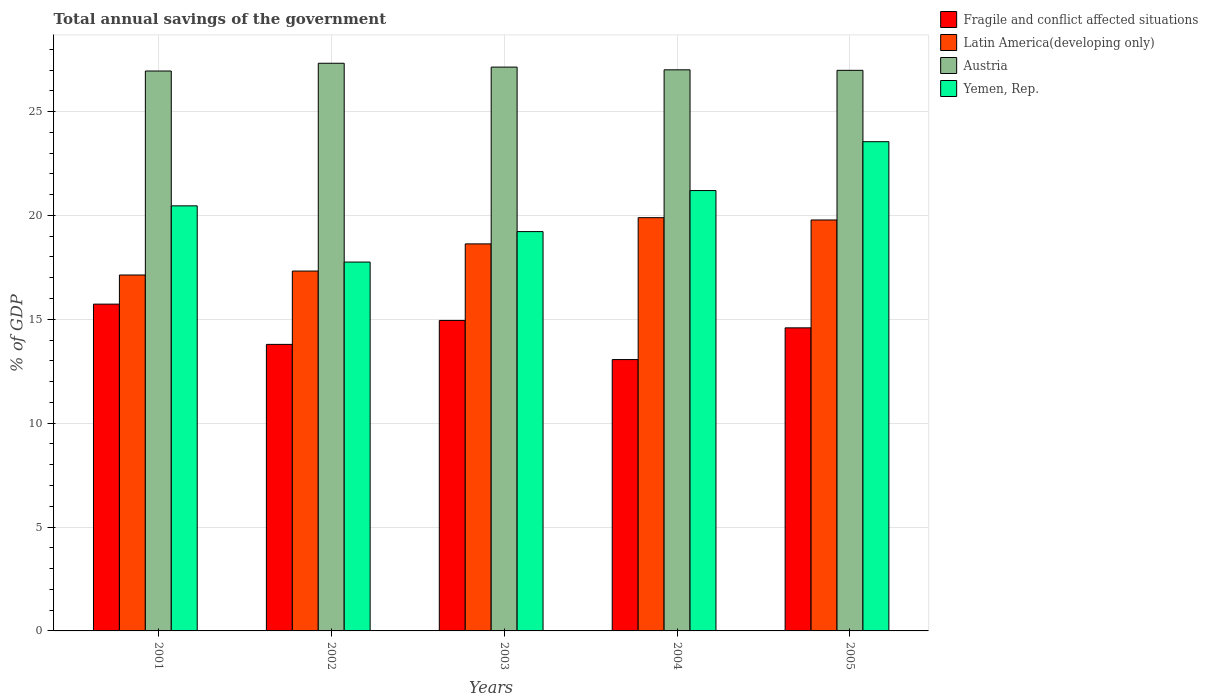How many different coloured bars are there?
Provide a succinct answer. 4. Are the number of bars per tick equal to the number of legend labels?
Provide a short and direct response. Yes. Are the number of bars on each tick of the X-axis equal?
Your answer should be compact. Yes. How many bars are there on the 2nd tick from the left?
Offer a terse response. 4. In how many cases, is the number of bars for a given year not equal to the number of legend labels?
Offer a very short reply. 0. What is the total annual savings of the government in Austria in 2005?
Your response must be concise. 26.99. Across all years, what is the maximum total annual savings of the government in Yemen, Rep.?
Your answer should be compact. 23.55. Across all years, what is the minimum total annual savings of the government in Yemen, Rep.?
Keep it short and to the point. 17.76. In which year was the total annual savings of the government in Fragile and conflict affected situations maximum?
Your answer should be compact. 2001. In which year was the total annual savings of the government in Austria minimum?
Make the answer very short. 2001. What is the total total annual savings of the government in Austria in the graph?
Give a very brief answer. 135.41. What is the difference between the total annual savings of the government in Latin America(developing only) in 2002 and that in 2003?
Keep it short and to the point. -1.31. What is the difference between the total annual savings of the government in Austria in 2003 and the total annual savings of the government in Latin America(developing only) in 2004?
Provide a succinct answer. 7.25. What is the average total annual savings of the government in Austria per year?
Provide a short and direct response. 27.08. In the year 2002, what is the difference between the total annual savings of the government in Yemen, Rep. and total annual savings of the government in Latin America(developing only)?
Make the answer very short. 0.43. In how many years, is the total annual savings of the government in Latin America(developing only) greater than 15 %?
Offer a terse response. 5. What is the ratio of the total annual savings of the government in Latin America(developing only) in 2003 to that in 2004?
Your answer should be compact. 0.94. What is the difference between the highest and the second highest total annual savings of the government in Fragile and conflict affected situations?
Ensure brevity in your answer.  0.79. What is the difference between the highest and the lowest total annual savings of the government in Yemen, Rep.?
Keep it short and to the point. 5.79. Is it the case that in every year, the sum of the total annual savings of the government in Fragile and conflict affected situations and total annual savings of the government in Austria is greater than the sum of total annual savings of the government in Yemen, Rep. and total annual savings of the government in Latin America(developing only)?
Your response must be concise. Yes. What does the 4th bar from the left in 2004 represents?
Ensure brevity in your answer.  Yemen, Rep. What does the 4th bar from the right in 2005 represents?
Offer a very short reply. Fragile and conflict affected situations. Is it the case that in every year, the sum of the total annual savings of the government in Austria and total annual savings of the government in Yemen, Rep. is greater than the total annual savings of the government in Fragile and conflict affected situations?
Your answer should be very brief. Yes. What is the difference between two consecutive major ticks on the Y-axis?
Keep it short and to the point. 5. Does the graph contain grids?
Your answer should be very brief. Yes. How many legend labels are there?
Offer a terse response. 4. What is the title of the graph?
Give a very brief answer. Total annual savings of the government. What is the label or title of the Y-axis?
Ensure brevity in your answer.  % of GDP. What is the % of GDP in Fragile and conflict affected situations in 2001?
Provide a succinct answer. 15.73. What is the % of GDP of Latin America(developing only) in 2001?
Offer a very short reply. 17.13. What is the % of GDP in Austria in 2001?
Provide a succinct answer. 26.95. What is the % of GDP of Yemen, Rep. in 2001?
Offer a very short reply. 20.46. What is the % of GDP in Fragile and conflict affected situations in 2002?
Keep it short and to the point. 13.79. What is the % of GDP in Latin America(developing only) in 2002?
Keep it short and to the point. 17.32. What is the % of GDP of Austria in 2002?
Ensure brevity in your answer.  27.33. What is the % of GDP in Yemen, Rep. in 2002?
Make the answer very short. 17.76. What is the % of GDP in Fragile and conflict affected situations in 2003?
Your answer should be very brief. 14.95. What is the % of GDP in Latin America(developing only) in 2003?
Your answer should be compact. 18.63. What is the % of GDP in Austria in 2003?
Ensure brevity in your answer.  27.14. What is the % of GDP of Yemen, Rep. in 2003?
Give a very brief answer. 19.22. What is the % of GDP of Fragile and conflict affected situations in 2004?
Make the answer very short. 13.06. What is the % of GDP in Latin America(developing only) in 2004?
Offer a terse response. 19.89. What is the % of GDP of Austria in 2004?
Provide a succinct answer. 27.01. What is the % of GDP of Yemen, Rep. in 2004?
Offer a terse response. 21.2. What is the % of GDP of Fragile and conflict affected situations in 2005?
Provide a short and direct response. 14.59. What is the % of GDP of Latin America(developing only) in 2005?
Your answer should be compact. 19.78. What is the % of GDP in Austria in 2005?
Your answer should be compact. 26.99. What is the % of GDP in Yemen, Rep. in 2005?
Your response must be concise. 23.55. Across all years, what is the maximum % of GDP in Fragile and conflict affected situations?
Your response must be concise. 15.73. Across all years, what is the maximum % of GDP in Latin America(developing only)?
Your answer should be compact. 19.89. Across all years, what is the maximum % of GDP of Austria?
Ensure brevity in your answer.  27.33. Across all years, what is the maximum % of GDP of Yemen, Rep.?
Keep it short and to the point. 23.55. Across all years, what is the minimum % of GDP in Fragile and conflict affected situations?
Provide a short and direct response. 13.06. Across all years, what is the minimum % of GDP in Latin America(developing only)?
Provide a short and direct response. 17.13. Across all years, what is the minimum % of GDP in Austria?
Your answer should be compact. 26.95. Across all years, what is the minimum % of GDP of Yemen, Rep.?
Provide a succinct answer. 17.76. What is the total % of GDP in Fragile and conflict affected situations in the graph?
Keep it short and to the point. 72.12. What is the total % of GDP of Latin America(developing only) in the graph?
Provide a short and direct response. 92.76. What is the total % of GDP of Austria in the graph?
Offer a very short reply. 135.41. What is the total % of GDP in Yemen, Rep. in the graph?
Keep it short and to the point. 102.19. What is the difference between the % of GDP in Fragile and conflict affected situations in 2001 and that in 2002?
Offer a very short reply. 1.94. What is the difference between the % of GDP of Latin America(developing only) in 2001 and that in 2002?
Your answer should be compact. -0.19. What is the difference between the % of GDP in Austria in 2001 and that in 2002?
Offer a very short reply. -0.37. What is the difference between the % of GDP of Yemen, Rep. in 2001 and that in 2002?
Offer a terse response. 2.71. What is the difference between the % of GDP of Fragile and conflict affected situations in 2001 and that in 2003?
Provide a short and direct response. 0.79. What is the difference between the % of GDP of Latin America(developing only) in 2001 and that in 2003?
Ensure brevity in your answer.  -1.5. What is the difference between the % of GDP in Austria in 2001 and that in 2003?
Keep it short and to the point. -0.19. What is the difference between the % of GDP of Yemen, Rep. in 2001 and that in 2003?
Keep it short and to the point. 1.24. What is the difference between the % of GDP in Fragile and conflict affected situations in 2001 and that in 2004?
Keep it short and to the point. 2.67. What is the difference between the % of GDP in Latin America(developing only) in 2001 and that in 2004?
Provide a short and direct response. -2.76. What is the difference between the % of GDP of Austria in 2001 and that in 2004?
Your answer should be compact. -0.06. What is the difference between the % of GDP of Yemen, Rep. in 2001 and that in 2004?
Give a very brief answer. -0.74. What is the difference between the % of GDP in Fragile and conflict affected situations in 2001 and that in 2005?
Offer a terse response. 1.14. What is the difference between the % of GDP in Latin America(developing only) in 2001 and that in 2005?
Offer a very short reply. -2.65. What is the difference between the % of GDP of Austria in 2001 and that in 2005?
Make the answer very short. -0.03. What is the difference between the % of GDP of Yemen, Rep. in 2001 and that in 2005?
Keep it short and to the point. -3.09. What is the difference between the % of GDP in Fragile and conflict affected situations in 2002 and that in 2003?
Your response must be concise. -1.15. What is the difference between the % of GDP in Latin America(developing only) in 2002 and that in 2003?
Your answer should be very brief. -1.31. What is the difference between the % of GDP in Austria in 2002 and that in 2003?
Ensure brevity in your answer.  0.19. What is the difference between the % of GDP of Yemen, Rep. in 2002 and that in 2003?
Offer a terse response. -1.47. What is the difference between the % of GDP in Fragile and conflict affected situations in 2002 and that in 2004?
Your answer should be very brief. 0.73. What is the difference between the % of GDP of Latin America(developing only) in 2002 and that in 2004?
Give a very brief answer. -2.57. What is the difference between the % of GDP in Austria in 2002 and that in 2004?
Provide a short and direct response. 0.32. What is the difference between the % of GDP in Yemen, Rep. in 2002 and that in 2004?
Your answer should be compact. -3.44. What is the difference between the % of GDP of Fragile and conflict affected situations in 2002 and that in 2005?
Keep it short and to the point. -0.8. What is the difference between the % of GDP in Latin America(developing only) in 2002 and that in 2005?
Provide a short and direct response. -2.46. What is the difference between the % of GDP of Austria in 2002 and that in 2005?
Your answer should be very brief. 0.34. What is the difference between the % of GDP in Yemen, Rep. in 2002 and that in 2005?
Offer a terse response. -5.79. What is the difference between the % of GDP in Fragile and conflict affected situations in 2003 and that in 2004?
Provide a succinct answer. 1.88. What is the difference between the % of GDP in Latin America(developing only) in 2003 and that in 2004?
Offer a terse response. -1.26. What is the difference between the % of GDP in Austria in 2003 and that in 2004?
Your answer should be compact. 0.13. What is the difference between the % of GDP of Yemen, Rep. in 2003 and that in 2004?
Give a very brief answer. -1.98. What is the difference between the % of GDP in Fragile and conflict affected situations in 2003 and that in 2005?
Make the answer very short. 0.36. What is the difference between the % of GDP in Latin America(developing only) in 2003 and that in 2005?
Make the answer very short. -1.15. What is the difference between the % of GDP in Austria in 2003 and that in 2005?
Provide a succinct answer. 0.16. What is the difference between the % of GDP in Yemen, Rep. in 2003 and that in 2005?
Make the answer very short. -4.33. What is the difference between the % of GDP of Fragile and conflict affected situations in 2004 and that in 2005?
Provide a short and direct response. -1.53. What is the difference between the % of GDP of Austria in 2004 and that in 2005?
Your answer should be compact. 0.02. What is the difference between the % of GDP in Yemen, Rep. in 2004 and that in 2005?
Your answer should be very brief. -2.35. What is the difference between the % of GDP of Fragile and conflict affected situations in 2001 and the % of GDP of Latin America(developing only) in 2002?
Your answer should be compact. -1.59. What is the difference between the % of GDP of Fragile and conflict affected situations in 2001 and the % of GDP of Austria in 2002?
Provide a succinct answer. -11.6. What is the difference between the % of GDP of Fragile and conflict affected situations in 2001 and the % of GDP of Yemen, Rep. in 2002?
Your answer should be compact. -2.03. What is the difference between the % of GDP of Latin America(developing only) in 2001 and the % of GDP of Austria in 2002?
Make the answer very short. -10.19. What is the difference between the % of GDP in Latin America(developing only) in 2001 and the % of GDP in Yemen, Rep. in 2002?
Make the answer very short. -0.62. What is the difference between the % of GDP in Austria in 2001 and the % of GDP in Yemen, Rep. in 2002?
Your answer should be compact. 9.2. What is the difference between the % of GDP of Fragile and conflict affected situations in 2001 and the % of GDP of Latin America(developing only) in 2003?
Keep it short and to the point. -2.9. What is the difference between the % of GDP of Fragile and conflict affected situations in 2001 and the % of GDP of Austria in 2003?
Give a very brief answer. -11.41. What is the difference between the % of GDP of Fragile and conflict affected situations in 2001 and the % of GDP of Yemen, Rep. in 2003?
Your answer should be compact. -3.49. What is the difference between the % of GDP in Latin America(developing only) in 2001 and the % of GDP in Austria in 2003?
Ensure brevity in your answer.  -10.01. What is the difference between the % of GDP in Latin America(developing only) in 2001 and the % of GDP in Yemen, Rep. in 2003?
Your response must be concise. -2.09. What is the difference between the % of GDP of Austria in 2001 and the % of GDP of Yemen, Rep. in 2003?
Give a very brief answer. 7.73. What is the difference between the % of GDP of Fragile and conflict affected situations in 2001 and the % of GDP of Latin America(developing only) in 2004?
Provide a short and direct response. -4.16. What is the difference between the % of GDP in Fragile and conflict affected situations in 2001 and the % of GDP in Austria in 2004?
Make the answer very short. -11.28. What is the difference between the % of GDP of Fragile and conflict affected situations in 2001 and the % of GDP of Yemen, Rep. in 2004?
Make the answer very short. -5.47. What is the difference between the % of GDP of Latin America(developing only) in 2001 and the % of GDP of Austria in 2004?
Keep it short and to the point. -9.88. What is the difference between the % of GDP in Latin America(developing only) in 2001 and the % of GDP in Yemen, Rep. in 2004?
Ensure brevity in your answer.  -4.06. What is the difference between the % of GDP in Austria in 2001 and the % of GDP in Yemen, Rep. in 2004?
Provide a succinct answer. 5.76. What is the difference between the % of GDP of Fragile and conflict affected situations in 2001 and the % of GDP of Latin America(developing only) in 2005?
Make the answer very short. -4.05. What is the difference between the % of GDP in Fragile and conflict affected situations in 2001 and the % of GDP in Austria in 2005?
Your answer should be very brief. -11.25. What is the difference between the % of GDP of Fragile and conflict affected situations in 2001 and the % of GDP of Yemen, Rep. in 2005?
Keep it short and to the point. -7.82. What is the difference between the % of GDP in Latin America(developing only) in 2001 and the % of GDP in Austria in 2005?
Offer a very short reply. -9.85. What is the difference between the % of GDP in Latin America(developing only) in 2001 and the % of GDP in Yemen, Rep. in 2005?
Provide a short and direct response. -6.42. What is the difference between the % of GDP of Austria in 2001 and the % of GDP of Yemen, Rep. in 2005?
Make the answer very short. 3.4. What is the difference between the % of GDP in Fragile and conflict affected situations in 2002 and the % of GDP in Latin America(developing only) in 2003?
Give a very brief answer. -4.84. What is the difference between the % of GDP in Fragile and conflict affected situations in 2002 and the % of GDP in Austria in 2003?
Keep it short and to the point. -13.35. What is the difference between the % of GDP in Fragile and conflict affected situations in 2002 and the % of GDP in Yemen, Rep. in 2003?
Offer a very short reply. -5.43. What is the difference between the % of GDP of Latin America(developing only) in 2002 and the % of GDP of Austria in 2003?
Offer a terse response. -9.82. What is the difference between the % of GDP in Latin America(developing only) in 2002 and the % of GDP in Yemen, Rep. in 2003?
Offer a terse response. -1.9. What is the difference between the % of GDP in Austria in 2002 and the % of GDP in Yemen, Rep. in 2003?
Keep it short and to the point. 8.1. What is the difference between the % of GDP in Fragile and conflict affected situations in 2002 and the % of GDP in Latin America(developing only) in 2004?
Give a very brief answer. -6.1. What is the difference between the % of GDP of Fragile and conflict affected situations in 2002 and the % of GDP of Austria in 2004?
Your answer should be very brief. -13.22. What is the difference between the % of GDP of Fragile and conflict affected situations in 2002 and the % of GDP of Yemen, Rep. in 2004?
Keep it short and to the point. -7.41. What is the difference between the % of GDP in Latin America(developing only) in 2002 and the % of GDP in Austria in 2004?
Your response must be concise. -9.69. What is the difference between the % of GDP of Latin America(developing only) in 2002 and the % of GDP of Yemen, Rep. in 2004?
Your response must be concise. -3.88. What is the difference between the % of GDP of Austria in 2002 and the % of GDP of Yemen, Rep. in 2004?
Give a very brief answer. 6.13. What is the difference between the % of GDP in Fragile and conflict affected situations in 2002 and the % of GDP in Latin America(developing only) in 2005?
Your answer should be compact. -5.99. What is the difference between the % of GDP of Fragile and conflict affected situations in 2002 and the % of GDP of Austria in 2005?
Provide a short and direct response. -13.19. What is the difference between the % of GDP in Fragile and conflict affected situations in 2002 and the % of GDP in Yemen, Rep. in 2005?
Keep it short and to the point. -9.76. What is the difference between the % of GDP in Latin America(developing only) in 2002 and the % of GDP in Austria in 2005?
Give a very brief answer. -9.66. What is the difference between the % of GDP in Latin America(developing only) in 2002 and the % of GDP in Yemen, Rep. in 2005?
Give a very brief answer. -6.23. What is the difference between the % of GDP in Austria in 2002 and the % of GDP in Yemen, Rep. in 2005?
Your answer should be very brief. 3.78. What is the difference between the % of GDP in Fragile and conflict affected situations in 2003 and the % of GDP in Latin America(developing only) in 2004?
Ensure brevity in your answer.  -4.95. What is the difference between the % of GDP in Fragile and conflict affected situations in 2003 and the % of GDP in Austria in 2004?
Offer a very short reply. -12.06. What is the difference between the % of GDP in Fragile and conflict affected situations in 2003 and the % of GDP in Yemen, Rep. in 2004?
Provide a short and direct response. -6.25. What is the difference between the % of GDP in Latin America(developing only) in 2003 and the % of GDP in Austria in 2004?
Give a very brief answer. -8.38. What is the difference between the % of GDP of Latin America(developing only) in 2003 and the % of GDP of Yemen, Rep. in 2004?
Your answer should be compact. -2.57. What is the difference between the % of GDP in Austria in 2003 and the % of GDP in Yemen, Rep. in 2004?
Give a very brief answer. 5.94. What is the difference between the % of GDP in Fragile and conflict affected situations in 2003 and the % of GDP in Latin America(developing only) in 2005?
Your answer should be compact. -4.84. What is the difference between the % of GDP in Fragile and conflict affected situations in 2003 and the % of GDP in Austria in 2005?
Keep it short and to the point. -12.04. What is the difference between the % of GDP in Fragile and conflict affected situations in 2003 and the % of GDP in Yemen, Rep. in 2005?
Your answer should be compact. -8.6. What is the difference between the % of GDP of Latin America(developing only) in 2003 and the % of GDP of Austria in 2005?
Make the answer very short. -8.35. What is the difference between the % of GDP of Latin America(developing only) in 2003 and the % of GDP of Yemen, Rep. in 2005?
Your response must be concise. -4.92. What is the difference between the % of GDP of Austria in 2003 and the % of GDP of Yemen, Rep. in 2005?
Keep it short and to the point. 3.59. What is the difference between the % of GDP of Fragile and conflict affected situations in 2004 and the % of GDP of Latin America(developing only) in 2005?
Keep it short and to the point. -6.72. What is the difference between the % of GDP in Fragile and conflict affected situations in 2004 and the % of GDP in Austria in 2005?
Your response must be concise. -13.92. What is the difference between the % of GDP of Fragile and conflict affected situations in 2004 and the % of GDP of Yemen, Rep. in 2005?
Your answer should be very brief. -10.49. What is the difference between the % of GDP of Latin America(developing only) in 2004 and the % of GDP of Austria in 2005?
Your answer should be compact. -7.09. What is the difference between the % of GDP of Latin America(developing only) in 2004 and the % of GDP of Yemen, Rep. in 2005?
Keep it short and to the point. -3.66. What is the difference between the % of GDP of Austria in 2004 and the % of GDP of Yemen, Rep. in 2005?
Keep it short and to the point. 3.46. What is the average % of GDP in Fragile and conflict affected situations per year?
Provide a short and direct response. 14.42. What is the average % of GDP in Latin America(developing only) per year?
Provide a succinct answer. 18.55. What is the average % of GDP of Austria per year?
Provide a short and direct response. 27.08. What is the average % of GDP in Yemen, Rep. per year?
Offer a terse response. 20.44. In the year 2001, what is the difference between the % of GDP in Fragile and conflict affected situations and % of GDP in Latin America(developing only)?
Make the answer very short. -1.4. In the year 2001, what is the difference between the % of GDP of Fragile and conflict affected situations and % of GDP of Austria?
Provide a short and direct response. -11.22. In the year 2001, what is the difference between the % of GDP of Fragile and conflict affected situations and % of GDP of Yemen, Rep.?
Give a very brief answer. -4.73. In the year 2001, what is the difference between the % of GDP in Latin America(developing only) and % of GDP in Austria?
Make the answer very short. -9.82. In the year 2001, what is the difference between the % of GDP in Latin America(developing only) and % of GDP in Yemen, Rep.?
Make the answer very short. -3.33. In the year 2001, what is the difference between the % of GDP of Austria and % of GDP of Yemen, Rep.?
Give a very brief answer. 6.49. In the year 2002, what is the difference between the % of GDP of Fragile and conflict affected situations and % of GDP of Latin America(developing only)?
Your answer should be compact. -3.53. In the year 2002, what is the difference between the % of GDP of Fragile and conflict affected situations and % of GDP of Austria?
Keep it short and to the point. -13.53. In the year 2002, what is the difference between the % of GDP of Fragile and conflict affected situations and % of GDP of Yemen, Rep.?
Offer a very short reply. -3.96. In the year 2002, what is the difference between the % of GDP in Latin America(developing only) and % of GDP in Austria?
Provide a short and direct response. -10. In the year 2002, what is the difference between the % of GDP in Latin America(developing only) and % of GDP in Yemen, Rep.?
Your response must be concise. -0.43. In the year 2002, what is the difference between the % of GDP in Austria and % of GDP in Yemen, Rep.?
Provide a succinct answer. 9.57. In the year 2003, what is the difference between the % of GDP in Fragile and conflict affected situations and % of GDP in Latin America(developing only)?
Make the answer very short. -3.69. In the year 2003, what is the difference between the % of GDP of Fragile and conflict affected situations and % of GDP of Austria?
Keep it short and to the point. -12.2. In the year 2003, what is the difference between the % of GDP in Fragile and conflict affected situations and % of GDP in Yemen, Rep.?
Make the answer very short. -4.28. In the year 2003, what is the difference between the % of GDP in Latin America(developing only) and % of GDP in Austria?
Give a very brief answer. -8.51. In the year 2003, what is the difference between the % of GDP in Latin America(developing only) and % of GDP in Yemen, Rep.?
Give a very brief answer. -0.59. In the year 2003, what is the difference between the % of GDP in Austria and % of GDP in Yemen, Rep.?
Ensure brevity in your answer.  7.92. In the year 2004, what is the difference between the % of GDP of Fragile and conflict affected situations and % of GDP of Latin America(developing only)?
Make the answer very short. -6.83. In the year 2004, what is the difference between the % of GDP in Fragile and conflict affected situations and % of GDP in Austria?
Your answer should be compact. -13.95. In the year 2004, what is the difference between the % of GDP of Fragile and conflict affected situations and % of GDP of Yemen, Rep.?
Offer a very short reply. -8.14. In the year 2004, what is the difference between the % of GDP in Latin America(developing only) and % of GDP in Austria?
Offer a terse response. -7.12. In the year 2004, what is the difference between the % of GDP of Latin America(developing only) and % of GDP of Yemen, Rep.?
Your response must be concise. -1.3. In the year 2004, what is the difference between the % of GDP in Austria and % of GDP in Yemen, Rep.?
Offer a very short reply. 5.81. In the year 2005, what is the difference between the % of GDP in Fragile and conflict affected situations and % of GDP in Latin America(developing only)?
Keep it short and to the point. -5.19. In the year 2005, what is the difference between the % of GDP in Fragile and conflict affected situations and % of GDP in Austria?
Your answer should be very brief. -12.4. In the year 2005, what is the difference between the % of GDP in Fragile and conflict affected situations and % of GDP in Yemen, Rep.?
Offer a terse response. -8.96. In the year 2005, what is the difference between the % of GDP of Latin America(developing only) and % of GDP of Austria?
Offer a very short reply. -7.2. In the year 2005, what is the difference between the % of GDP of Latin America(developing only) and % of GDP of Yemen, Rep.?
Keep it short and to the point. -3.77. In the year 2005, what is the difference between the % of GDP of Austria and % of GDP of Yemen, Rep.?
Keep it short and to the point. 3.44. What is the ratio of the % of GDP of Fragile and conflict affected situations in 2001 to that in 2002?
Offer a very short reply. 1.14. What is the ratio of the % of GDP of Austria in 2001 to that in 2002?
Provide a short and direct response. 0.99. What is the ratio of the % of GDP in Yemen, Rep. in 2001 to that in 2002?
Make the answer very short. 1.15. What is the ratio of the % of GDP in Fragile and conflict affected situations in 2001 to that in 2003?
Make the answer very short. 1.05. What is the ratio of the % of GDP of Latin America(developing only) in 2001 to that in 2003?
Offer a terse response. 0.92. What is the ratio of the % of GDP in Yemen, Rep. in 2001 to that in 2003?
Your response must be concise. 1.06. What is the ratio of the % of GDP of Fragile and conflict affected situations in 2001 to that in 2004?
Your answer should be very brief. 1.2. What is the ratio of the % of GDP of Latin America(developing only) in 2001 to that in 2004?
Your answer should be compact. 0.86. What is the ratio of the % of GDP of Yemen, Rep. in 2001 to that in 2004?
Your answer should be compact. 0.97. What is the ratio of the % of GDP of Fragile and conflict affected situations in 2001 to that in 2005?
Ensure brevity in your answer.  1.08. What is the ratio of the % of GDP in Latin America(developing only) in 2001 to that in 2005?
Your answer should be very brief. 0.87. What is the ratio of the % of GDP in Austria in 2001 to that in 2005?
Offer a terse response. 1. What is the ratio of the % of GDP in Yemen, Rep. in 2001 to that in 2005?
Make the answer very short. 0.87. What is the ratio of the % of GDP of Fragile and conflict affected situations in 2002 to that in 2003?
Provide a short and direct response. 0.92. What is the ratio of the % of GDP in Latin America(developing only) in 2002 to that in 2003?
Ensure brevity in your answer.  0.93. What is the ratio of the % of GDP in Austria in 2002 to that in 2003?
Your response must be concise. 1.01. What is the ratio of the % of GDP in Yemen, Rep. in 2002 to that in 2003?
Your response must be concise. 0.92. What is the ratio of the % of GDP in Fragile and conflict affected situations in 2002 to that in 2004?
Offer a terse response. 1.06. What is the ratio of the % of GDP of Latin America(developing only) in 2002 to that in 2004?
Your answer should be very brief. 0.87. What is the ratio of the % of GDP in Austria in 2002 to that in 2004?
Give a very brief answer. 1.01. What is the ratio of the % of GDP in Yemen, Rep. in 2002 to that in 2004?
Offer a terse response. 0.84. What is the ratio of the % of GDP of Fragile and conflict affected situations in 2002 to that in 2005?
Offer a very short reply. 0.95. What is the ratio of the % of GDP in Latin America(developing only) in 2002 to that in 2005?
Ensure brevity in your answer.  0.88. What is the ratio of the % of GDP in Austria in 2002 to that in 2005?
Your response must be concise. 1.01. What is the ratio of the % of GDP in Yemen, Rep. in 2002 to that in 2005?
Make the answer very short. 0.75. What is the ratio of the % of GDP of Fragile and conflict affected situations in 2003 to that in 2004?
Your answer should be compact. 1.14. What is the ratio of the % of GDP in Latin America(developing only) in 2003 to that in 2004?
Give a very brief answer. 0.94. What is the ratio of the % of GDP in Yemen, Rep. in 2003 to that in 2004?
Ensure brevity in your answer.  0.91. What is the ratio of the % of GDP of Fragile and conflict affected situations in 2003 to that in 2005?
Your answer should be compact. 1.02. What is the ratio of the % of GDP in Latin America(developing only) in 2003 to that in 2005?
Give a very brief answer. 0.94. What is the ratio of the % of GDP of Yemen, Rep. in 2003 to that in 2005?
Offer a very short reply. 0.82. What is the ratio of the % of GDP in Fragile and conflict affected situations in 2004 to that in 2005?
Offer a very short reply. 0.9. What is the ratio of the % of GDP in Latin America(developing only) in 2004 to that in 2005?
Provide a short and direct response. 1.01. What is the ratio of the % of GDP of Yemen, Rep. in 2004 to that in 2005?
Your answer should be compact. 0.9. What is the difference between the highest and the second highest % of GDP of Fragile and conflict affected situations?
Provide a succinct answer. 0.79. What is the difference between the highest and the second highest % of GDP in Austria?
Keep it short and to the point. 0.19. What is the difference between the highest and the second highest % of GDP of Yemen, Rep.?
Offer a terse response. 2.35. What is the difference between the highest and the lowest % of GDP in Fragile and conflict affected situations?
Your response must be concise. 2.67. What is the difference between the highest and the lowest % of GDP of Latin America(developing only)?
Your answer should be compact. 2.76. What is the difference between the highest and the lowest % of GDP of Austria?
Give a very brief answer. 0.37. What is the difference between the highest and the lowest % of GDP of Yemen, Rep.?
Offer a terse response. 5.79. 